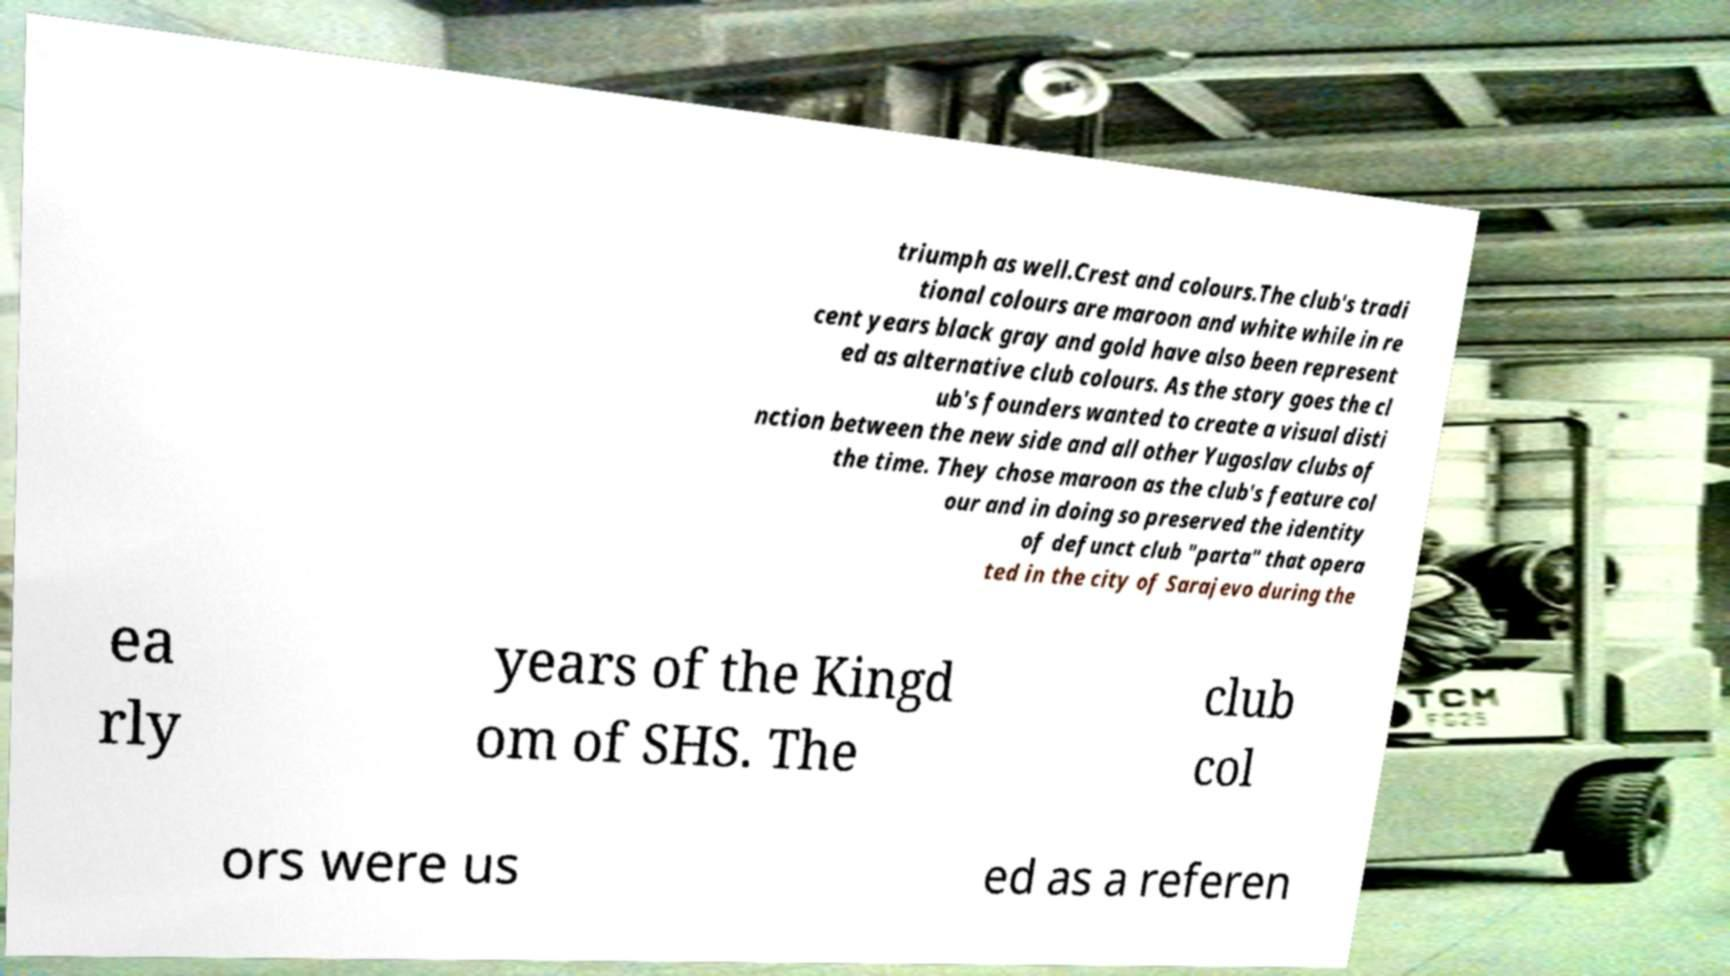Please read and relay the text visible in this image. What does it say? triumph as well.Crest and colours.The club's tradi tional colours are maroon and white while in re cent years black gray and gold have also been represent ed as alternative club colours. As the story goes the cl ub's founders wanted to create a visual disti nction between the new side and all other Yugoslav clubs of the time. They chose maroon as the club's feature col our and in doing so preserved the identity of defunct club "parta" that opera ted in the city of Sarajevo during the ea rly years of the Kingd om of SHS. The club col ors were us ed as a referen 